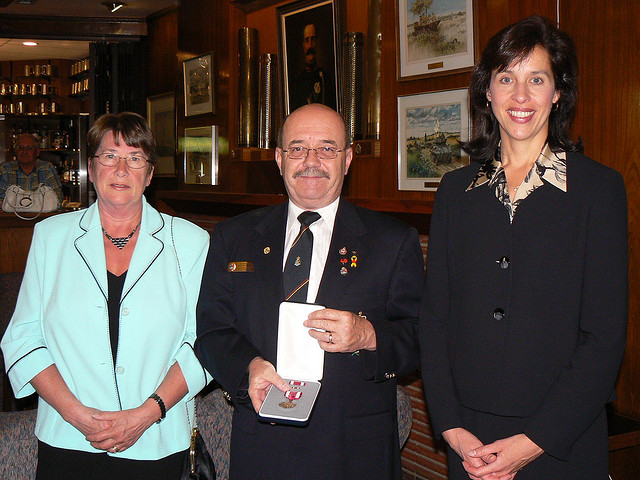Are there any notable decorations in the room? Yes, the room is adorned with framed pictures and paintings on the walls, which suggest that the event might be held in a place with historical significance or institutional importance. 